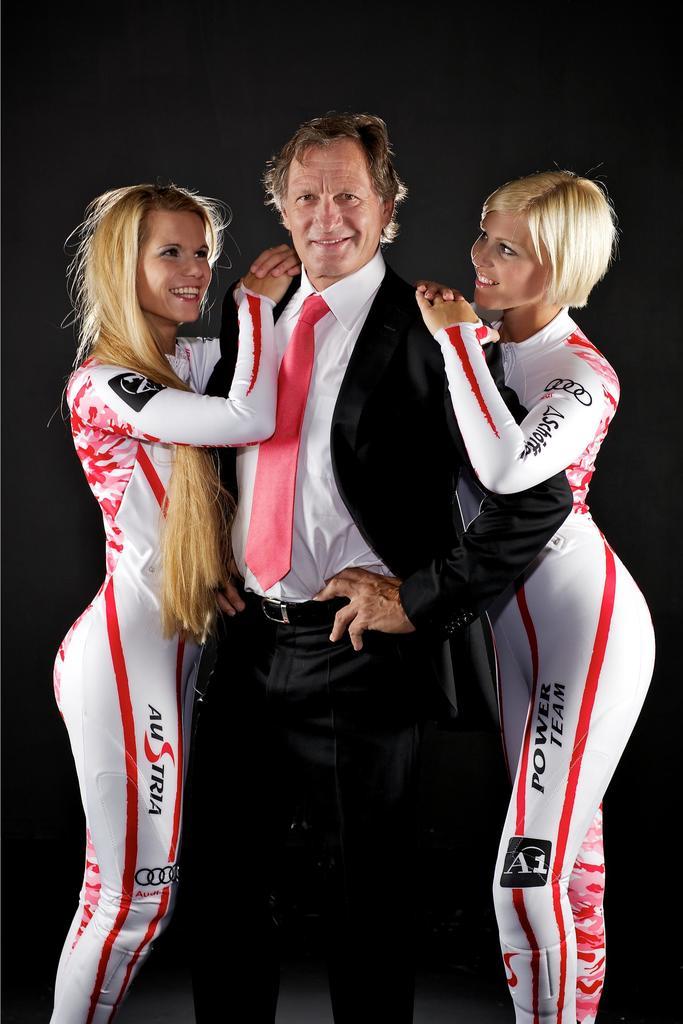What team is this?
Keep it short and to the point. Power team. What word has a red letter "s" in the middle?
Provide a short and direct response. Austria. 